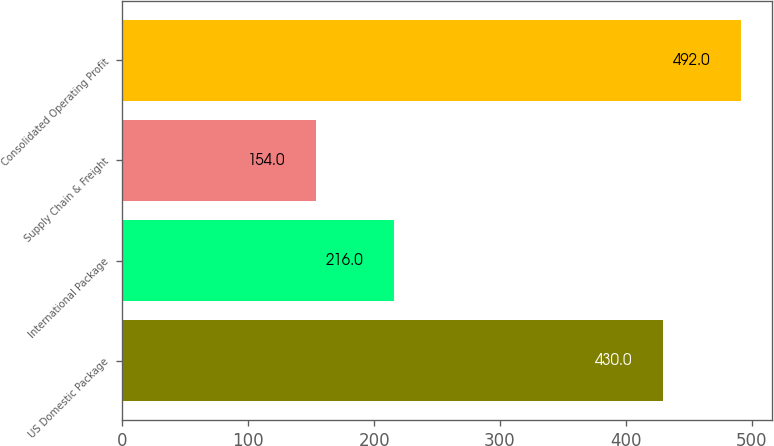Convert chart. <chart><loc_0><loc_0><loc_500><loc_500><bar_chart><fcel>US Domestic Package<fcel>International Package<fcel>Supply Chain & Freight<fcel>Consolidated Operating Profit<nl><fcel>430<fcel>216<fcel>154<fcel>492<nl></chart> 